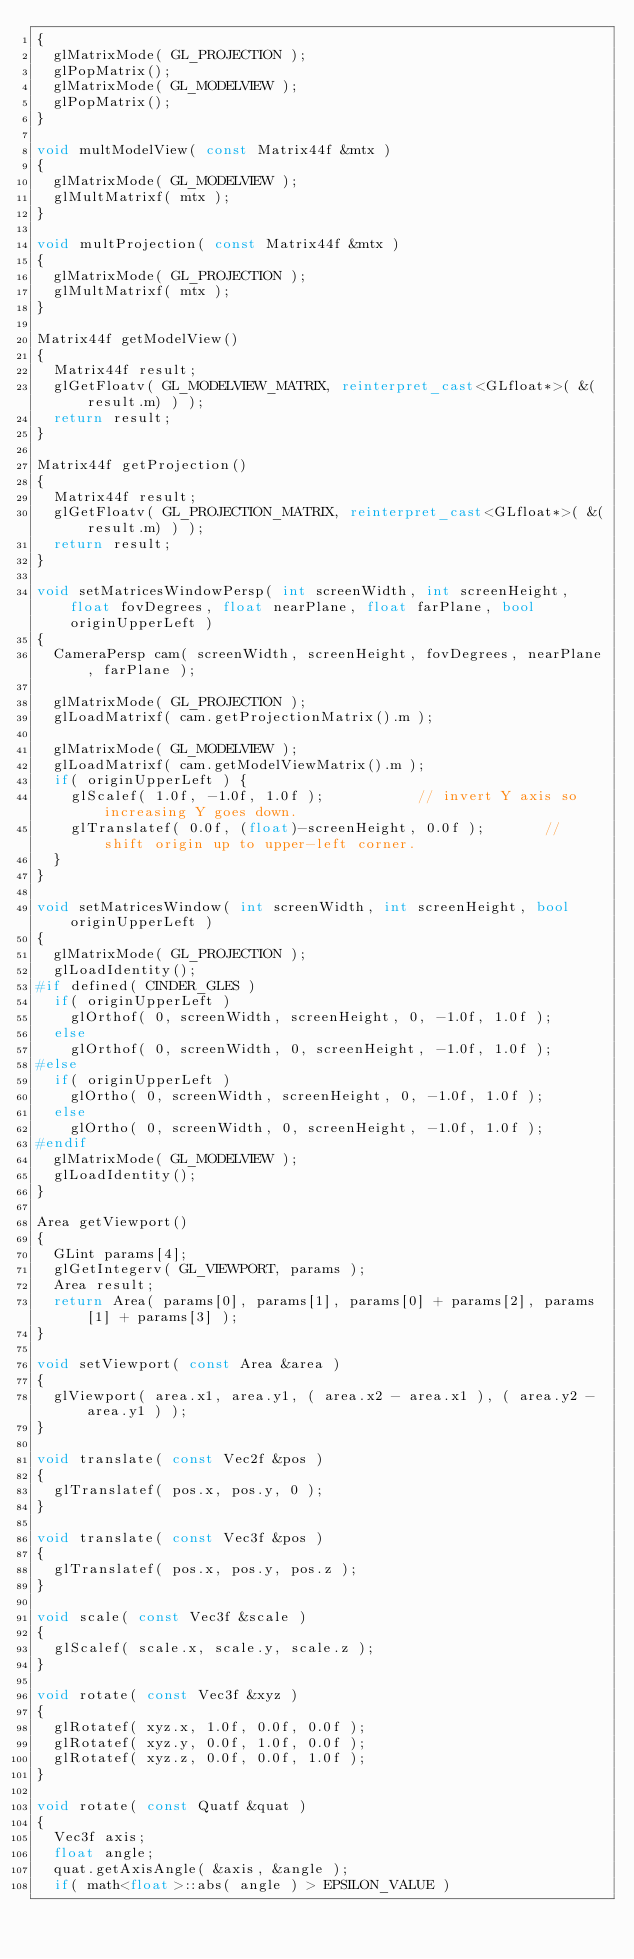<code> <loc_0><loc_0><loc_500><loc_500><_C++_>{
	glMatrixMode( GL_PROJECTION );
	glPopMatrix();
	glMatrixMode( GL_MODELVIEW );
	glPopMatrix();
}

void multModelView( const Matrix44f &mtx )
{
	glMatrixMode( GL_MODELVIEW );
	glMultMatrixf( mtx );
}

void multProjection( const Matrix44f &mtx )
{
	glMatrixMode( GL_PROJECTION );
	glMultMatrixf( mtx );
}

Matrix44f getModelView()
{
	Matrix44f result;
	glGetFloatv( GL_MODELVIEW_MATRIX, reinterpret_cast<GLfloat*>( &(result.m) ) );
	return result;
}

Matrix44f getProjection()
{
	Matrix44f result;
	glGetFloatv( GL_PROJECTION_MATRIX, reinterpret_cast<GLfloat*>( &(result.m) ) );
	return result;
}

void setMatricesWindowPersp( int screenWidth, int screenHeight, float fovDegrees, float nearPlane, float farPlane, bool originUpperLeft )
{
	CameraPersp cam( screenWidth, screenHeight, fovDegrees, nearPlane, farPlane );

	glMatrixMode( GL_PROJECTION );
	glLoadMatrixf( cam.getProjectionMatrix().m );

	glMatrixMode( GL_MODELVIEW );
	glLoadMatrixf( cam.getModelViewMatrix().m );
	if( originUpperLeft ) {
		glScalef( 1.0f, -1.0f, 1.0f );           // invert Y axis so increasing Y goes down.
		glTranslatef( 0.0f, (float)-screenHeight, 0.0f );       // shift origin up to upper-left corner.
	}
}

void setMatricesWindow( int screenWidth, int screenHeight, bool originUpperLeft )
{
	glMatrixMode( GL_PROJECTION );
	glLoadIdentity();
#if defined( CINDER_GLES )
	if( originUpperLeft )
		glOrthof( 0, screenWidth, screenHeight, 0, -1.0f, 1.0f );
	else
		glOrthof( 0, screenWidth, 0, screenHeight, -1.0f, 1.0f );
#else	
	if( originUpperLeft )
		glOrtho( 0, screenWidth, screenHeight, 0, -1.0f, 1.0f );
	else
		glOrtho( 0, screenWidth, 0, screenHeight, -1.0f, 1.0f );
#endif
	glMatrixMode( GL_MODELVIEW );
	glLoadIdentity();
}

Area getViewport()
{
	GLint params[4];
	glGetIntegerv( GL_VIEWPORT, params );
	Area result;
	return Area( params[0], params[1], params[0] + params[2], params[1] + params[3] );
}

void setViewport( const Area &area )
{
	glViewport( area.x1, area.y1, ( area.x2 - area.x1 ), ( area.y2 - area.y1 ) );
}

void translate( const Vec2f &pos )
{
	glTranslatef( pos.x, pos.y, 0 );
}

void translate( const Vec3f &pos )
{
	glTranslatef( pos.x, pos.y, pos.z );
}

void scale( const Vec3f &scale )
{
	glScalef( scale.x, scale.y, scale.z );
}

void rotate( const Vec3f &xyz )
{
	glRotatef( xyz.x, 1.0f, 0.0f, 0.0f );
	glRotatef( xyz.y, 0.0f, 1.0f, 0.0f );
	glRotatef( xyz.z, 0.0f, 0.0f, 1.0f );
}

void rotate( const Quatf &quat )
{
	Vec3f axis;
	float angle;
	quat.getAxisAngle( &axis, &angle );
	if( math<float>::abs( angle ) > EPSILON_VALUE )</code> 